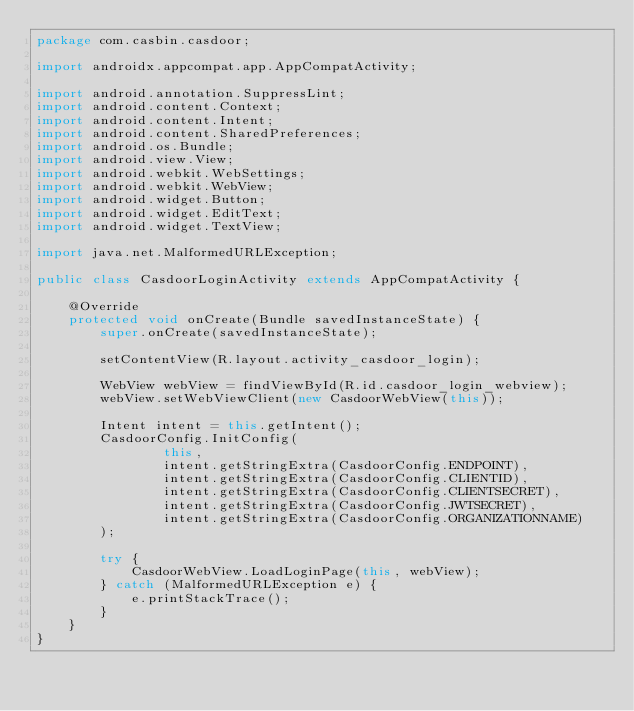<code> <loc_0><loc_0><loc_500><loc_500><_Java_>package com.casbin.casdoor;

import androidx.appcompat.app.AppCompatActivity;

import android.annotation.SuppressLint;
import android.content.Context;
import android.content.Intent;
import android.content.SharedPreferences;
import android.os.Bundle;
import android.view.View;
import android.webkit.WebSettings;
import android.webkit.WebView;
import android.widget.Button;
import android.widget.EditText;
import android.widget.TextView;

import java.net.MalformedURLException;

public class CasdoorLoginActivity extends AppCompatActivity {

    @Override
    protected void onCreate(Bundle savedInstanceState) {
        super.onCreate(savedInstanceState);

        setContentView(R.layout.activity_casdoor_login);

        WebView webView = findViewById(R.id.casdoor_login_webview);
        webView.setWebViewClient(new CasdoorWebView(this));

        Intent intent = this.getIntent();
        CasdoorConfig.InitConfig(
                this,
                intent.getStringExtra(CasdoorConfig.ENDPOINT),
                intent.getStringExtra(CasdoorConfig.CLIENTID),
                intent.getStringExtra(CasdoorConfig.CLIENTSECRET),
                intent.getStringExtra(CasdoorConfig.JWTSECRET),
                intent.getStringExtra(CasdoorConfig.ORGANIZATIONNAME)
        );

        try {
            CasdoorWebView.LoadLoginPage(this, webView);
        } catch (MalformedURLException e) {
            e.printStackTrace();
        }
    }
}
</code> 